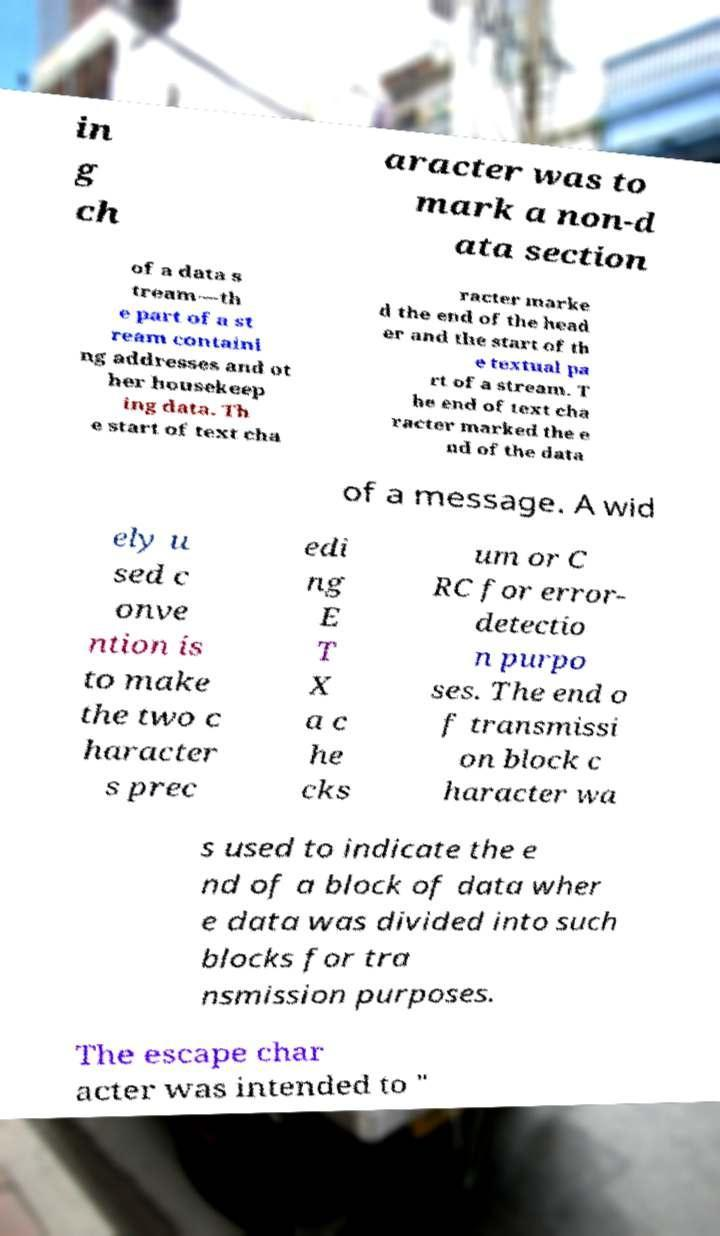Please identify and transcribe the text found in this image. in g ch aracter was to mark a non-d ata section of a data s tream—th e part of a st ream containi ng addresses and ot her housekeep ing data. Th e start of text cha racter marke d the end of the head er and the start of th e textual pa rt of a stream. T he end of text cha racter marked the e nd of the data of a message. A wid ely u sed c onve ntion is to make the two c haracter s prec edi ng E T X a c he cks um or C RC for error- detectio n purpo ses. The end o f transmissi on block c haracter wa s used to indicate the e nd of a block of data wher e data was divided into such blocks for tra nsmission purposes. The escape char acter was intended to " 